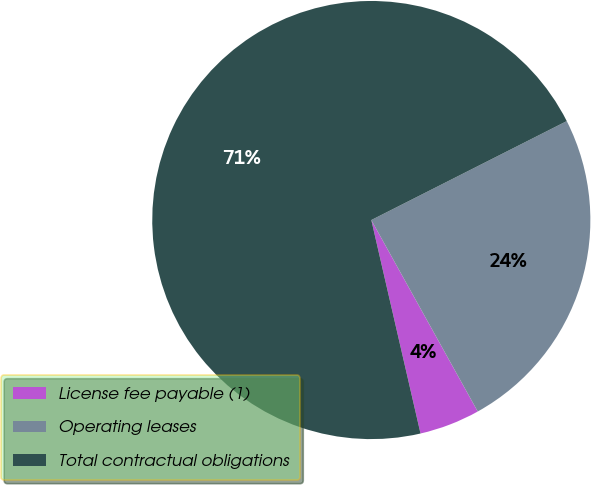<chart> <loc_0><loc_0><loc_500><loc_500><pie_chart><fcel>License fee payable (1)<fcel>Operating leases<fcel>Total contractual obligations<nl><fcel>4.47%<fcel>24.38%<fcel>71.14%<nl></chart> 